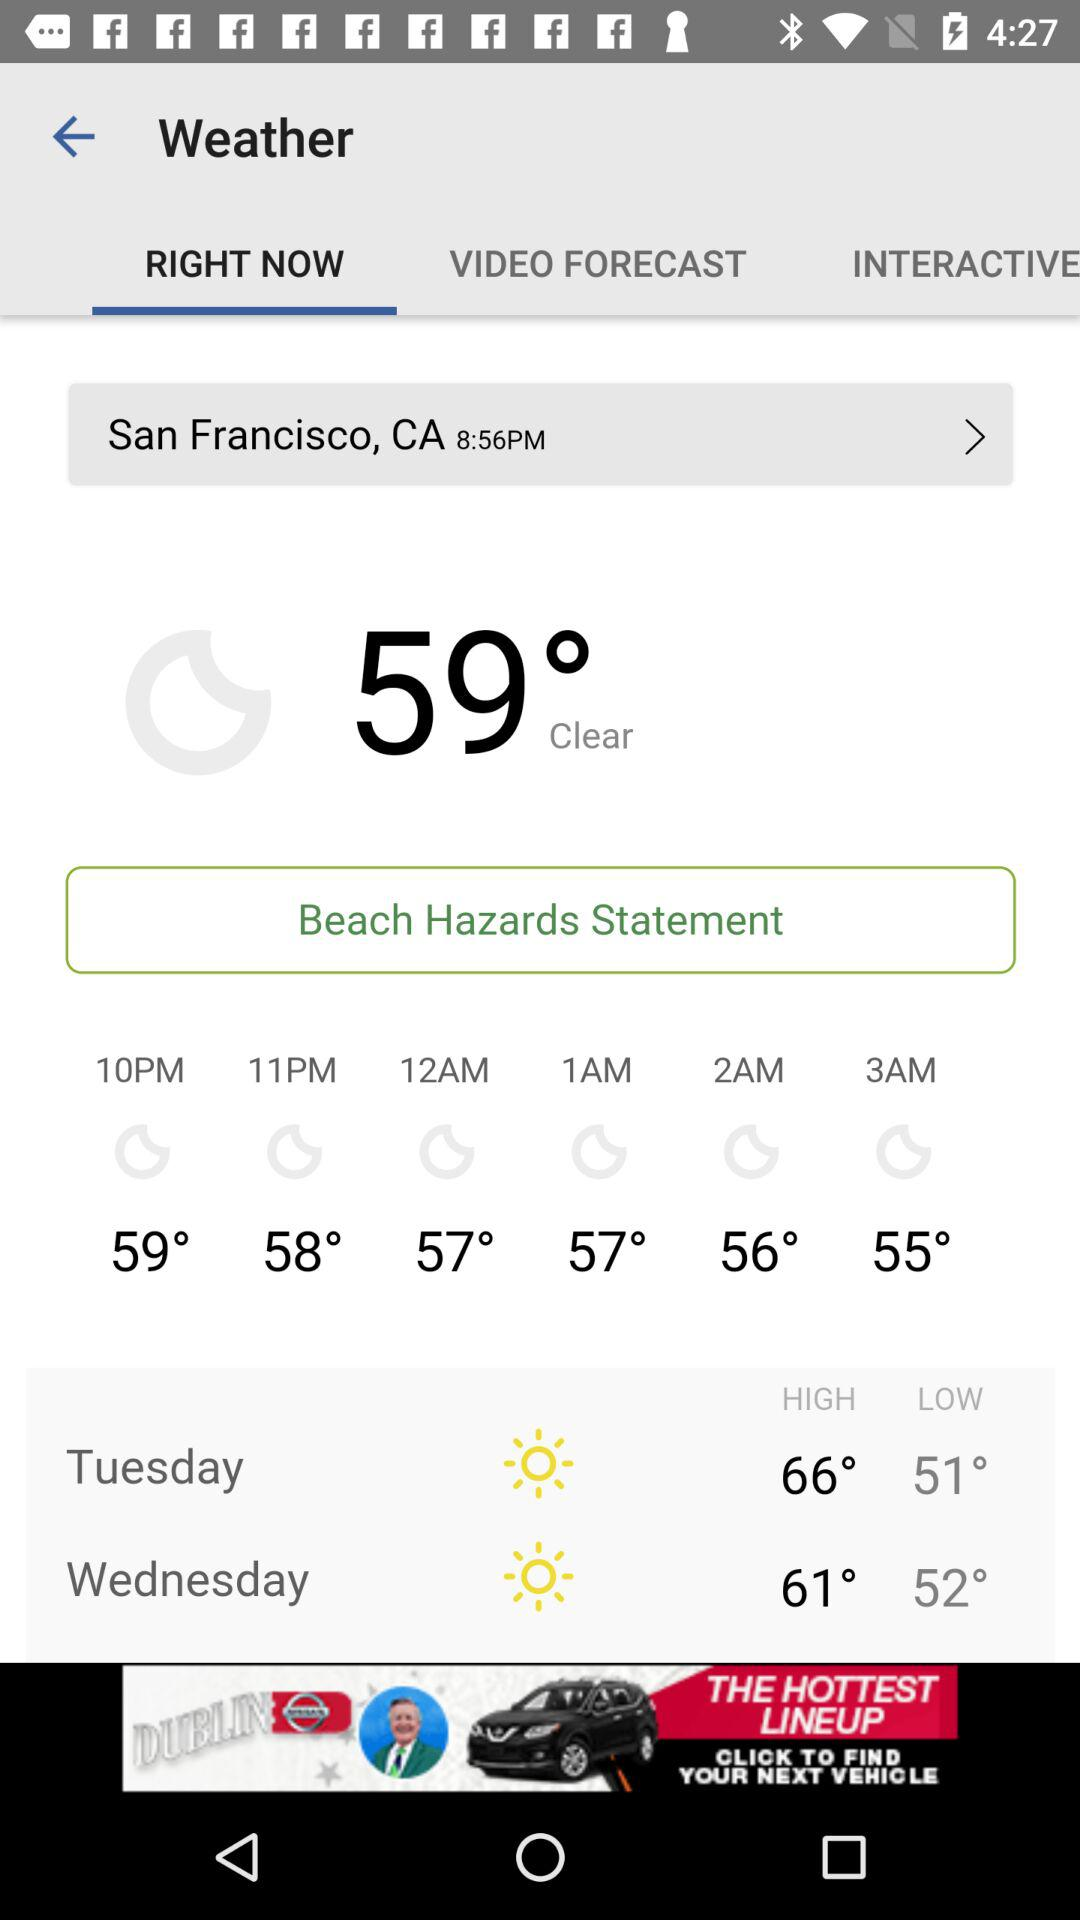What is the current location? The current location is "San Francisco, CA". 